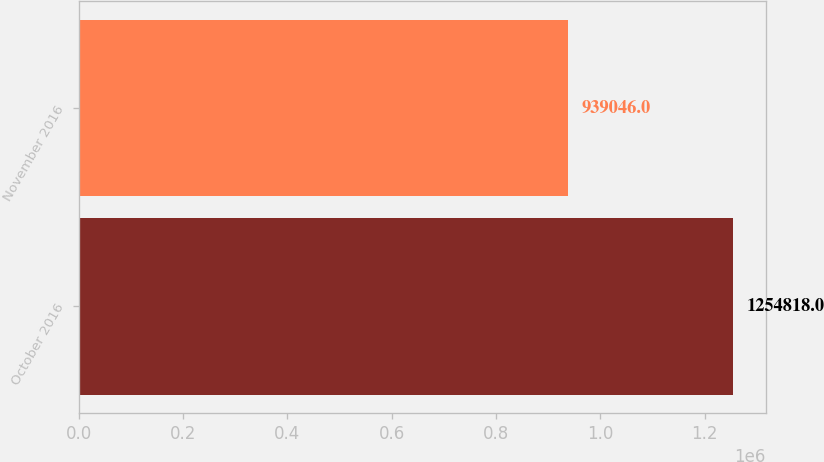Convert chart. <chart><loc_0><loc_0><loc_500><loc_500><bar_chart><fcel>October 2016<fcel>November 2016<nl><fcel>1.25482e+06<fcel>939046<nl></chart> 